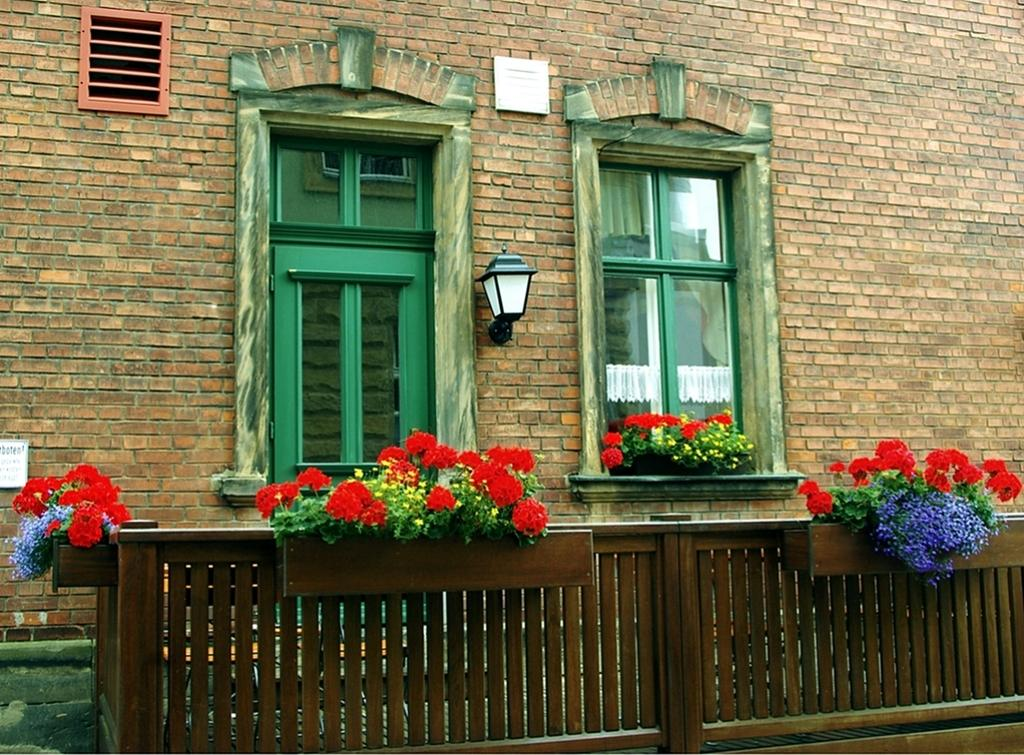What type of structure is visible in the image? There is a building in the image. What is located at the bottom of the image? There is a fence at the bottom of the image. What type of plants can be seen in the image? There are flowers in the image. What feature of the building is mentioned in the facts? There are windows in the building. How many balls are being juggled by the person in the image? There is no person or balls present in the image. What part of the body is visible on the person in the image? There is no person present in the image, so no body parts are visible. 